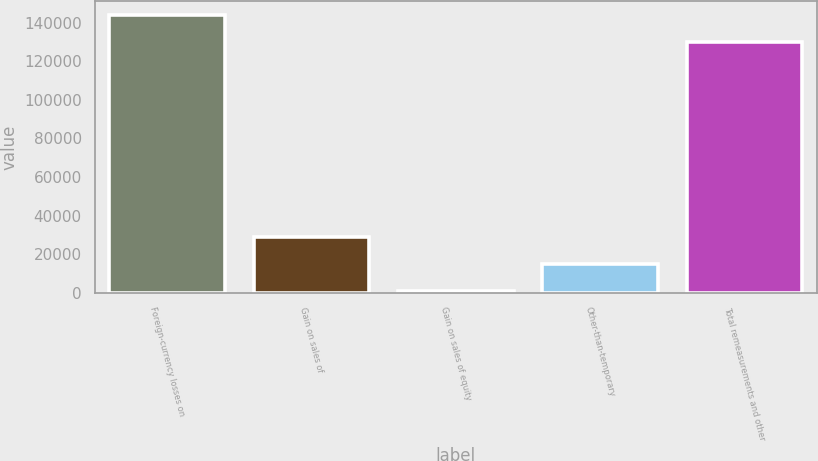<chart> <loc_0><loc_0><loc_500><loc_500><bar_chart><fcel>Foreign-currency losses on<fcel>Gain on sales of<fcel>Gain on sales of equity<fcel>Other-than-temporary<fcel>Total remeasurements and other<nl><fcel>144030<fcel>28662.8<fcel>796<fcel>14729.4<fcel>130097<nl></chart> 